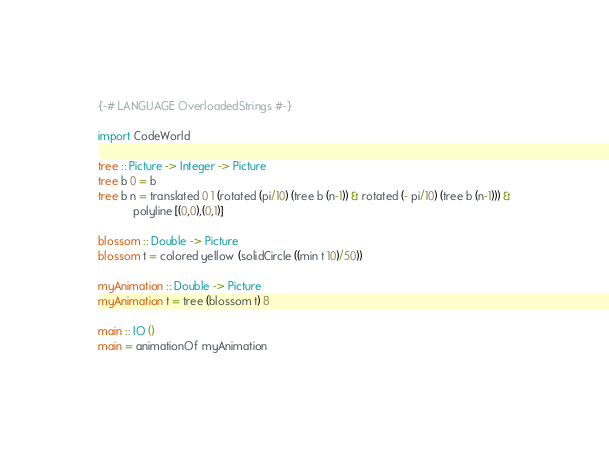Convert code to text. <code><loc_0><loc_0><loc_500><loc_500><_Haskell_>{-# LANGUAGE OverloadedStrings #-}

import CodeWorld

tree :: Picture -> Integer -> Picture
tree b 0 = b
tree b n = translated 0 1 (rotated (pi/10) (tree b (n-1)) & rotated (- pi/10) (tree b (n-1))) &
           polyline [(0,0),(0,1)]

blossom :: Double -> Picture
blossom t = colored yellow (solidCircle ((min t 10)/50))

myAnimation :: Double -> Picture
myAnimation t = tree (blossom t) 8

main :: IO ()
main = animationOf myAnimation
</code> 